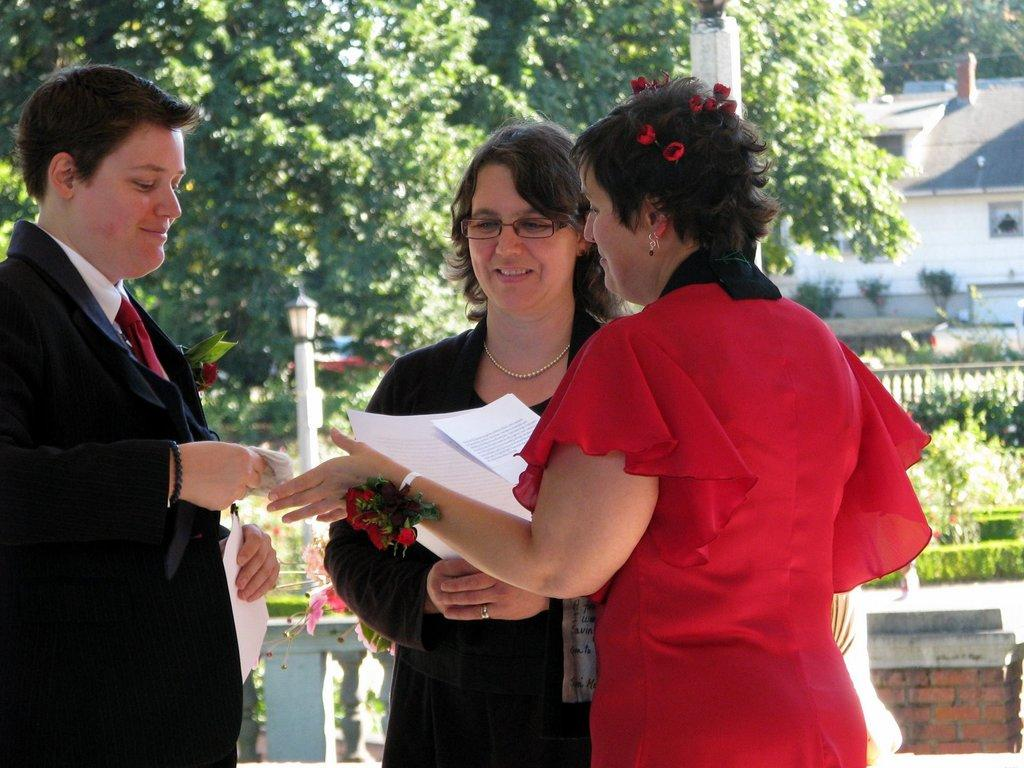How many people are present in the image? There are two women and a man in the image, making a total of three people. What are the individuals holding in their hands? They are holding papers in their hands. What is the facial expression of the people in the image? They are smiling. What can be seen in the background of the image? There is a building and trees in the background of the image. Can you see a squirrel climbing the tree in the image? There is no squirrel present in the image; it only features two women, a man, and the background with a building and trees. 